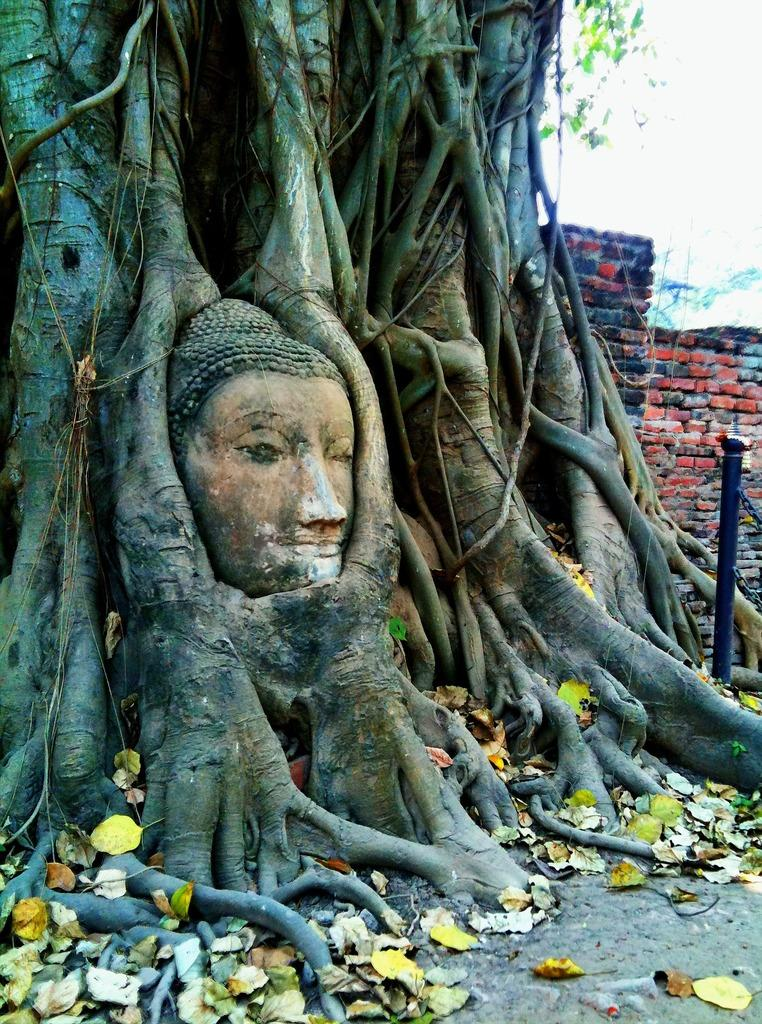What is the main subject in the image? There is a statue in the image. What other objects or features can be seen in the image? There is a tree, dried leaves, a pole, and a wall visible in the image. What is the condition of the sky in the background of the image? The sky is visible in the background of the image. What type of bread can be seen in the image? There is no bread present in the image. Is there any coal visible in the image? There is no coal present in the image. 